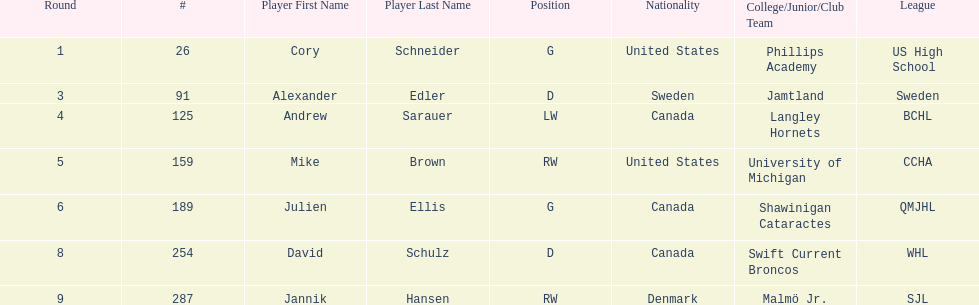Which players are not from denmark? Cory Schneider (G), Alexander Edler (D), Andrew Sarauer (LW), Mike Brown (RW), Julien Ellis (G), David Schulz (D). 